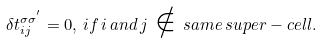<formula> <loc_0><loc_0><loc_500><loc_500>\delta t ^ { \sigma \sigma ^ { ^ { \prime } } } _ { i j } = 0 , \, i f \, i \, a n d \, j \, \notin \, s a m e \, s u p e r - c e l l .</formula> 